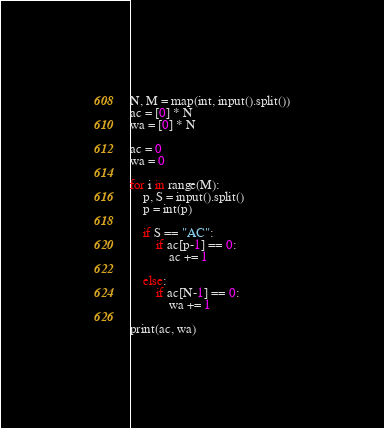<code> <loc_0><loc_0><loc_500><loc_500><_Python_>N, M = map(int, input().split())
ac = [0] * N
wa = [0] * N

ac = 0
wa = 0

for i in range(M):
    p, S = input().split()
    p = int(p)

    if S == "AC":
        if ac[p-1] == 0:
            ac += 1
            
    else:
        if ac[N-1] == 0:
            wa += 1

print(ac, wa)
</code> 